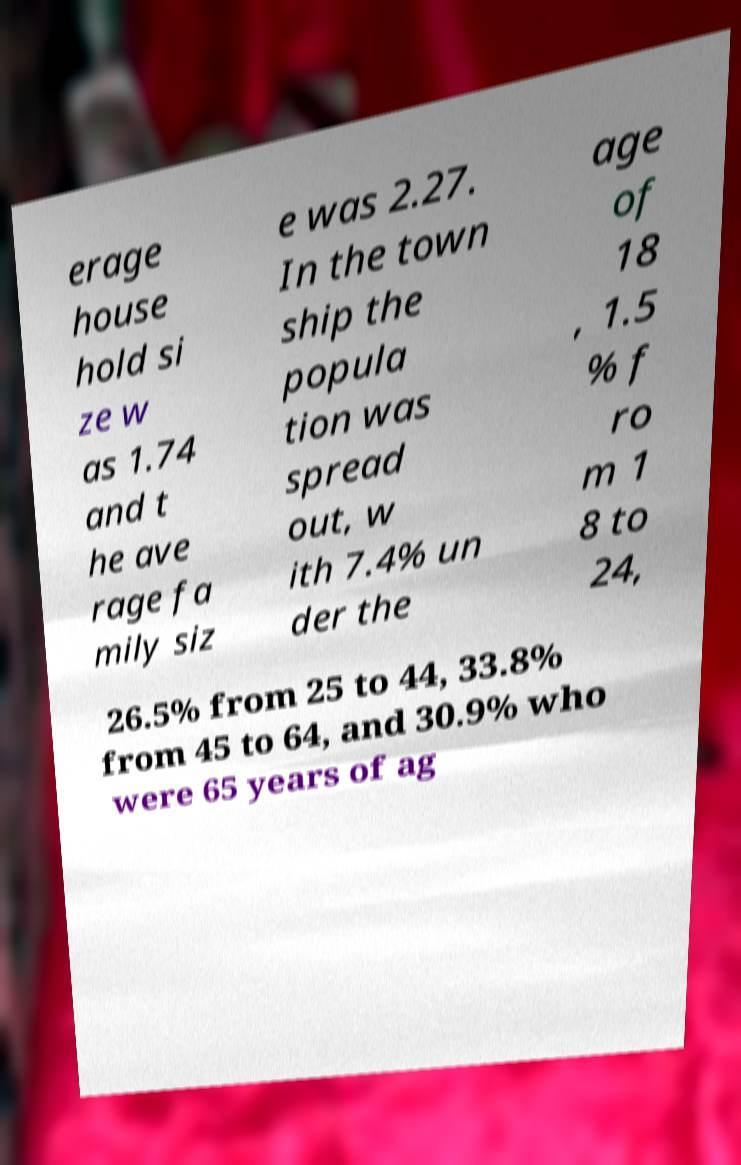Please identify and transcribe the text found in this image. erage house hold si ze w as 1.74 and t he ave rage fa mily siz e was 2.27. In the town ship the popula tion was spread out, w ith 7.4% un der the age of 18 , 1.5 % f ro m 1 8 to 24, 26.5% from 25 to 44, 33.8% from 45 to 64, and 30.9% who were 65 years of ag 